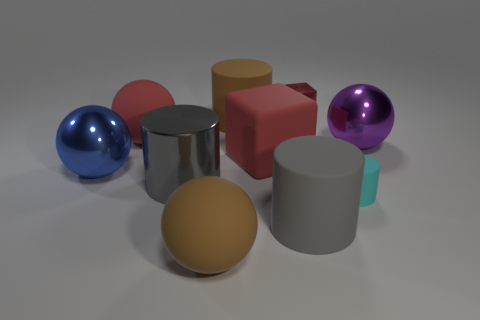What material is the other big cylinder that is the same color as the metal cylinder?
Your answer should be very brief. Rubber. What is the shape of the thing that is the same color as the metal cylinder?
Offer a very short reply. Cylinder. What is the size of the cyan rubber object that is the same shape as the gray metal object?
Give a very brief answer. Small. What number of things are large rubber balls that are behind the blue object or purple rubber cubes?
Give a very brief answer. 1. How many things are in front of the large rubber cylinder that is behind the tiny rubber cylinder?
Your response must be concise. 8. Are there fewer gray rubber things that are behind the brown rubber cylinder than large rubber balls that are in front of the gray metallic object?
Your answer should be compact. Yes. What shape is the large red matte thing that is on the left side of the big brown ball on the left side of the tiny rubber object?
Your answer should be compact. Sphere. What number of other things are the same material as the large purple ball?
Offer a very short reply. 3. Are there more shiny balls than things?
Keep it short and to the point. No. There is a sphere that is to the right of the big brown matte thing that is on the left side of the large brown thing behind the big rubber cube; what is its size?
Your answer should be very brief. Large. 